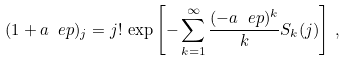Convert formula to latex. <formula><loc_0><loc_0><loc_500><loc_500>( 1 + a \ e p ) _ { j } = j ! \, \exp \left [ - \sum _ { k = 1 } ^ { \infty } \frac { ( - a \ e p ) ^ { k } } { k } S _ { k } ( j ) \right ] \, ,</formula> 